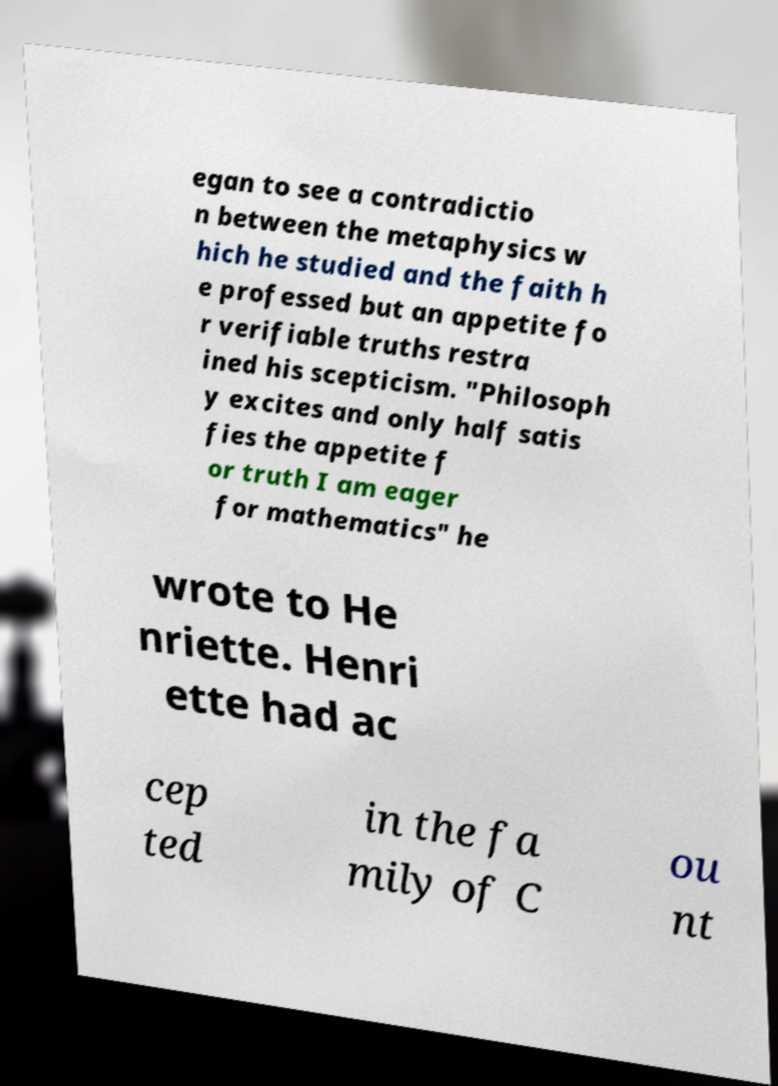Please identify and transcribe the text found in this image. egan to see a contradictio n between the metaphysics w hich he studied and the faith h e professed but an appetite fo r verifiable truths restra ined his scepticism. "Philosoph y excites and only half satis fies the appetite f or truth I am eager for mathematics" he wrote to He nriette. Henri ette had ac cep ted in the fa mily of C ou nt 